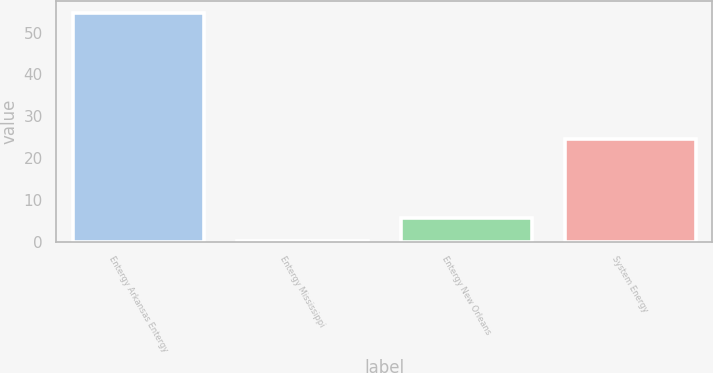Convert chart to OTSL. <chart><loc_0><loc_0><loc_500><loc_500><bar_chart><fcel>Entergy Arkansas Entergy<fcel>Entergy Mississippi<fcel>Entergy New Orleans<fcel>System Energy<nl><fcel>54.7<fcel>0.1<fcel>5.56<fcel>24.5<nl></chart> 